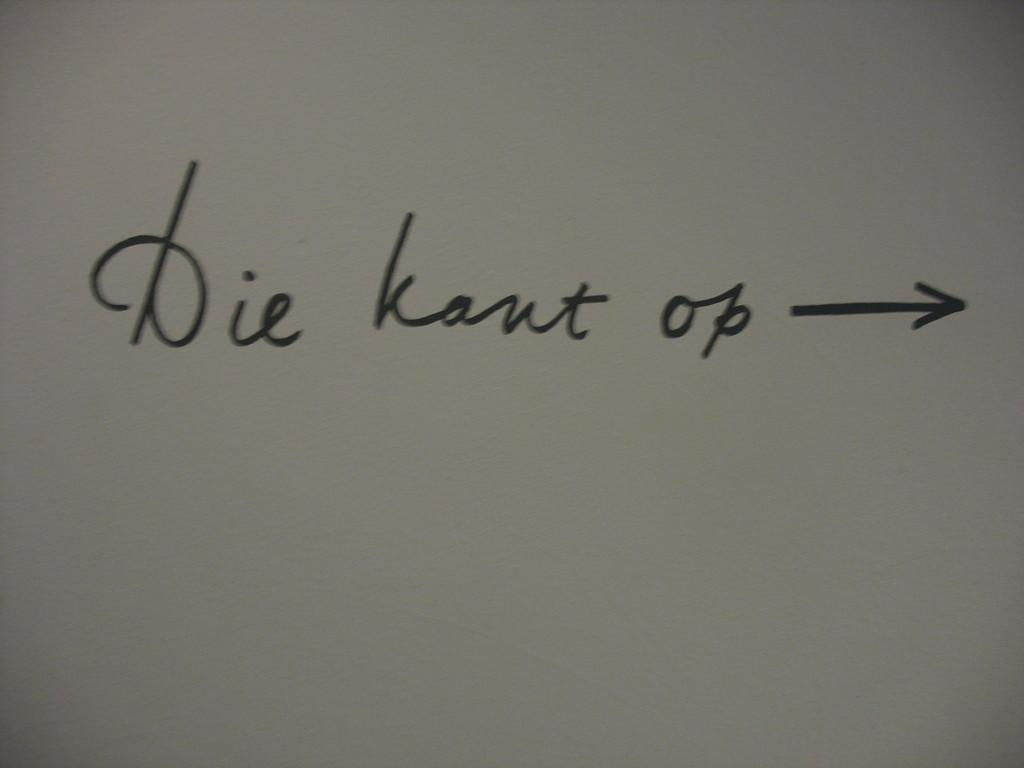Provide a one-sentence caption for the provided image. Wrote in cursing is die kant op with a arrow pointing right. 